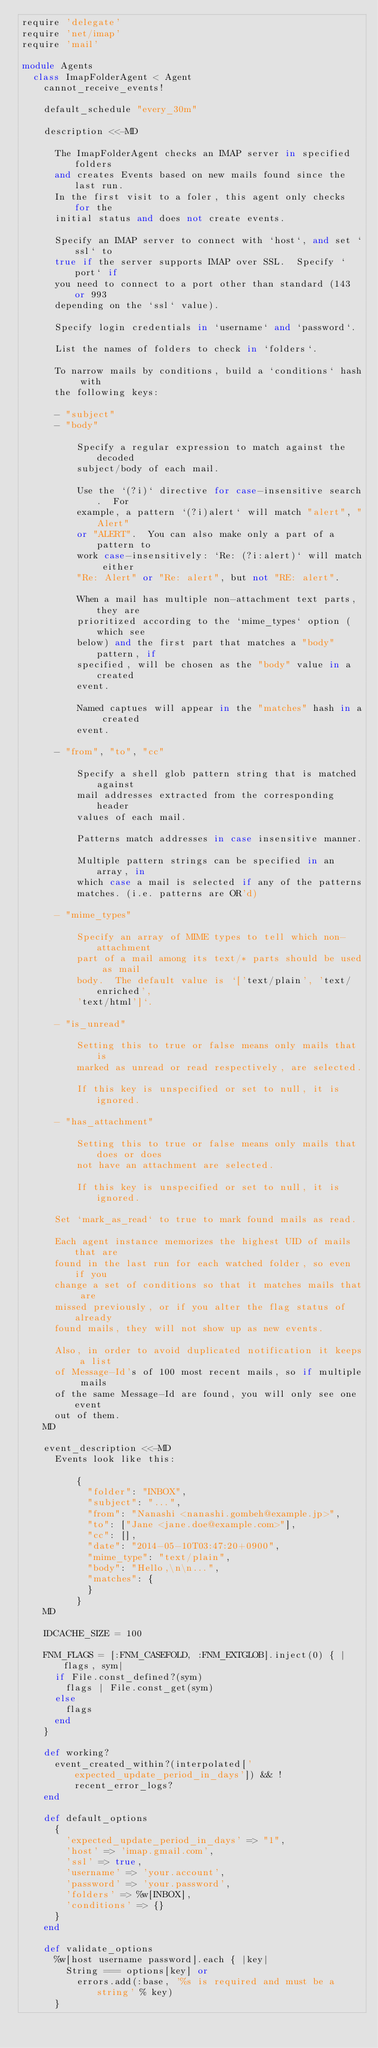<code> <loc_0><loc_0><loc_500><loc_500><_Ruby_>require 'delegate'
require 'net/imap'
require 'mail'

module Agents
  class ImapFolderAgent < Agent
    cannot_receive_events!

    default_schedule "every_30m"

    description <<-MD

      The ImapFolderAgent checks an IMAP server in specified folders
      and creates Events based on new mails found since the last run.
      In the first visit to a foler, this agent only checks for the
      initial status and does not create events.

      Specify an IMAP server to connect with `host`, and set `ssl` to
      true if the server supports IMAP over SSL.  Specify `port` if
      you need to connect to a port other than standard (143 or 993
      depending on the `ssl` value).

      Specify login credentials in `username` and `password`.

      List the names of folders to check in `folders`.

      To narrow mails by conditions, build a `conditions` hash with
      the following keys:

      - "subject"
      - "body"

          Specify a regular expression to match against the decoded
          subject/body of each mail.

          Use the `(?i)` directive for case-insensitive search.  For
          example, a pattern `(?i)alert` will match "alert", "Alert"
          or "ALERT".  You can also make only a part of a pattern to
          work case-insensitively: `Re: (?i:alert)` will match either
          "Re: Alert" or "Re: alert", but not "RE: alert".

          When a mail has multiple non-attachment text parts, they are
          prioritized according to the `mime_types` option (which see
          below) and the first part that matches a "body" pattern, if
          specified, will be chosen as the "body" value in a created
          event.

          Named captues will appear in the "matches" hash in a created
          event.

      - "from", "to", "cc"

          Specify a shell glob pattern string that is matched against
          mail addresses extracted from the corresponding header
          values of each mail.

          Patterns match addresses in case insensitive manner.

          Multiple pattern strings can be specified in an array, in
          which case a mail is selected if any of the patterns
          matches. (i.e. patterns are OR'd)

      - "mime_types"

          Specify an array of MIME types to tell which non-attachment
          part of a mail among its text/* parts should be used as mail
          body.  The default value is `['text/plain', 'text/enriched',
          'text/html']`.

      - "is_unread"

          Setting this to true or false means only mails that is
          marked as unread or read respectively, are selected.

          If this key is unspecified or set to null, it is ignored.

      - "has_attachment"

          Setting this to true or false means only mails that does or does
          not have an attachment are selected.

          If this key is unspecified or set to null, it is ignored.

      Set `mark_as_read` to true to mark found mails as read.

      Each agent instance memorizes the highest UID of mails that are
      found in the last run for each watched folder, so even if you
      change a set of conditions so that it matches mails that are
      missed previously, or if you alter the flag status of already
      found mails, they will not show up as new events.

      Also, in order to avoid duplicated notification it keeps a list
      of Message-Id's of 100 most recent mails, so if multiple mails
      of the same Message-Id are found, you will only see one event
      out of them.
    MD

    event_description <<-MD
      Events look like this:

          {
            "folder": "INBOX",
            "subject": "...",
            "from": "Nanashi <nanashi.gombeh@example.jp>",
            "to": ["Jane <jane.doe@example.com>"],
            "cc": [],
            "date": "2014-05-10T03:47:20+0900",
            "mime_type": "text/plain",
            "body": "Hello,\n\n...",
            "matches": {
            }
          }
    MD

    IDCACHE_SIZE = 100

    FNM_FLAGS = [:FNM_CASEFOLD, :FNM_EXTGLOB].inject(0) { |flags, sym|
      if File.const_defined?(sym)
        flags | File.const_get(sym)
      else
        flags
      end
    }

    def working?
      event_created_within?(interpolated['expected_update_period_in_days']) && !recent_error_logs?
    end

    def default_options
      {
        'expected_update_period_in_days' => "1",
        'host' => 'imap.gmail.com',
        'ssl' => true,
        'username' => 'your.account',
        'password' => 'your.password',
        'folders' => %w[INBOX],
        'conditions' => {}
      }
    end

    def validate_options
      %w[host username password].each { |key|
        String === options[key] or
          errors.add(:base, '%s is required and must be a string' % key)
      }
</code> 